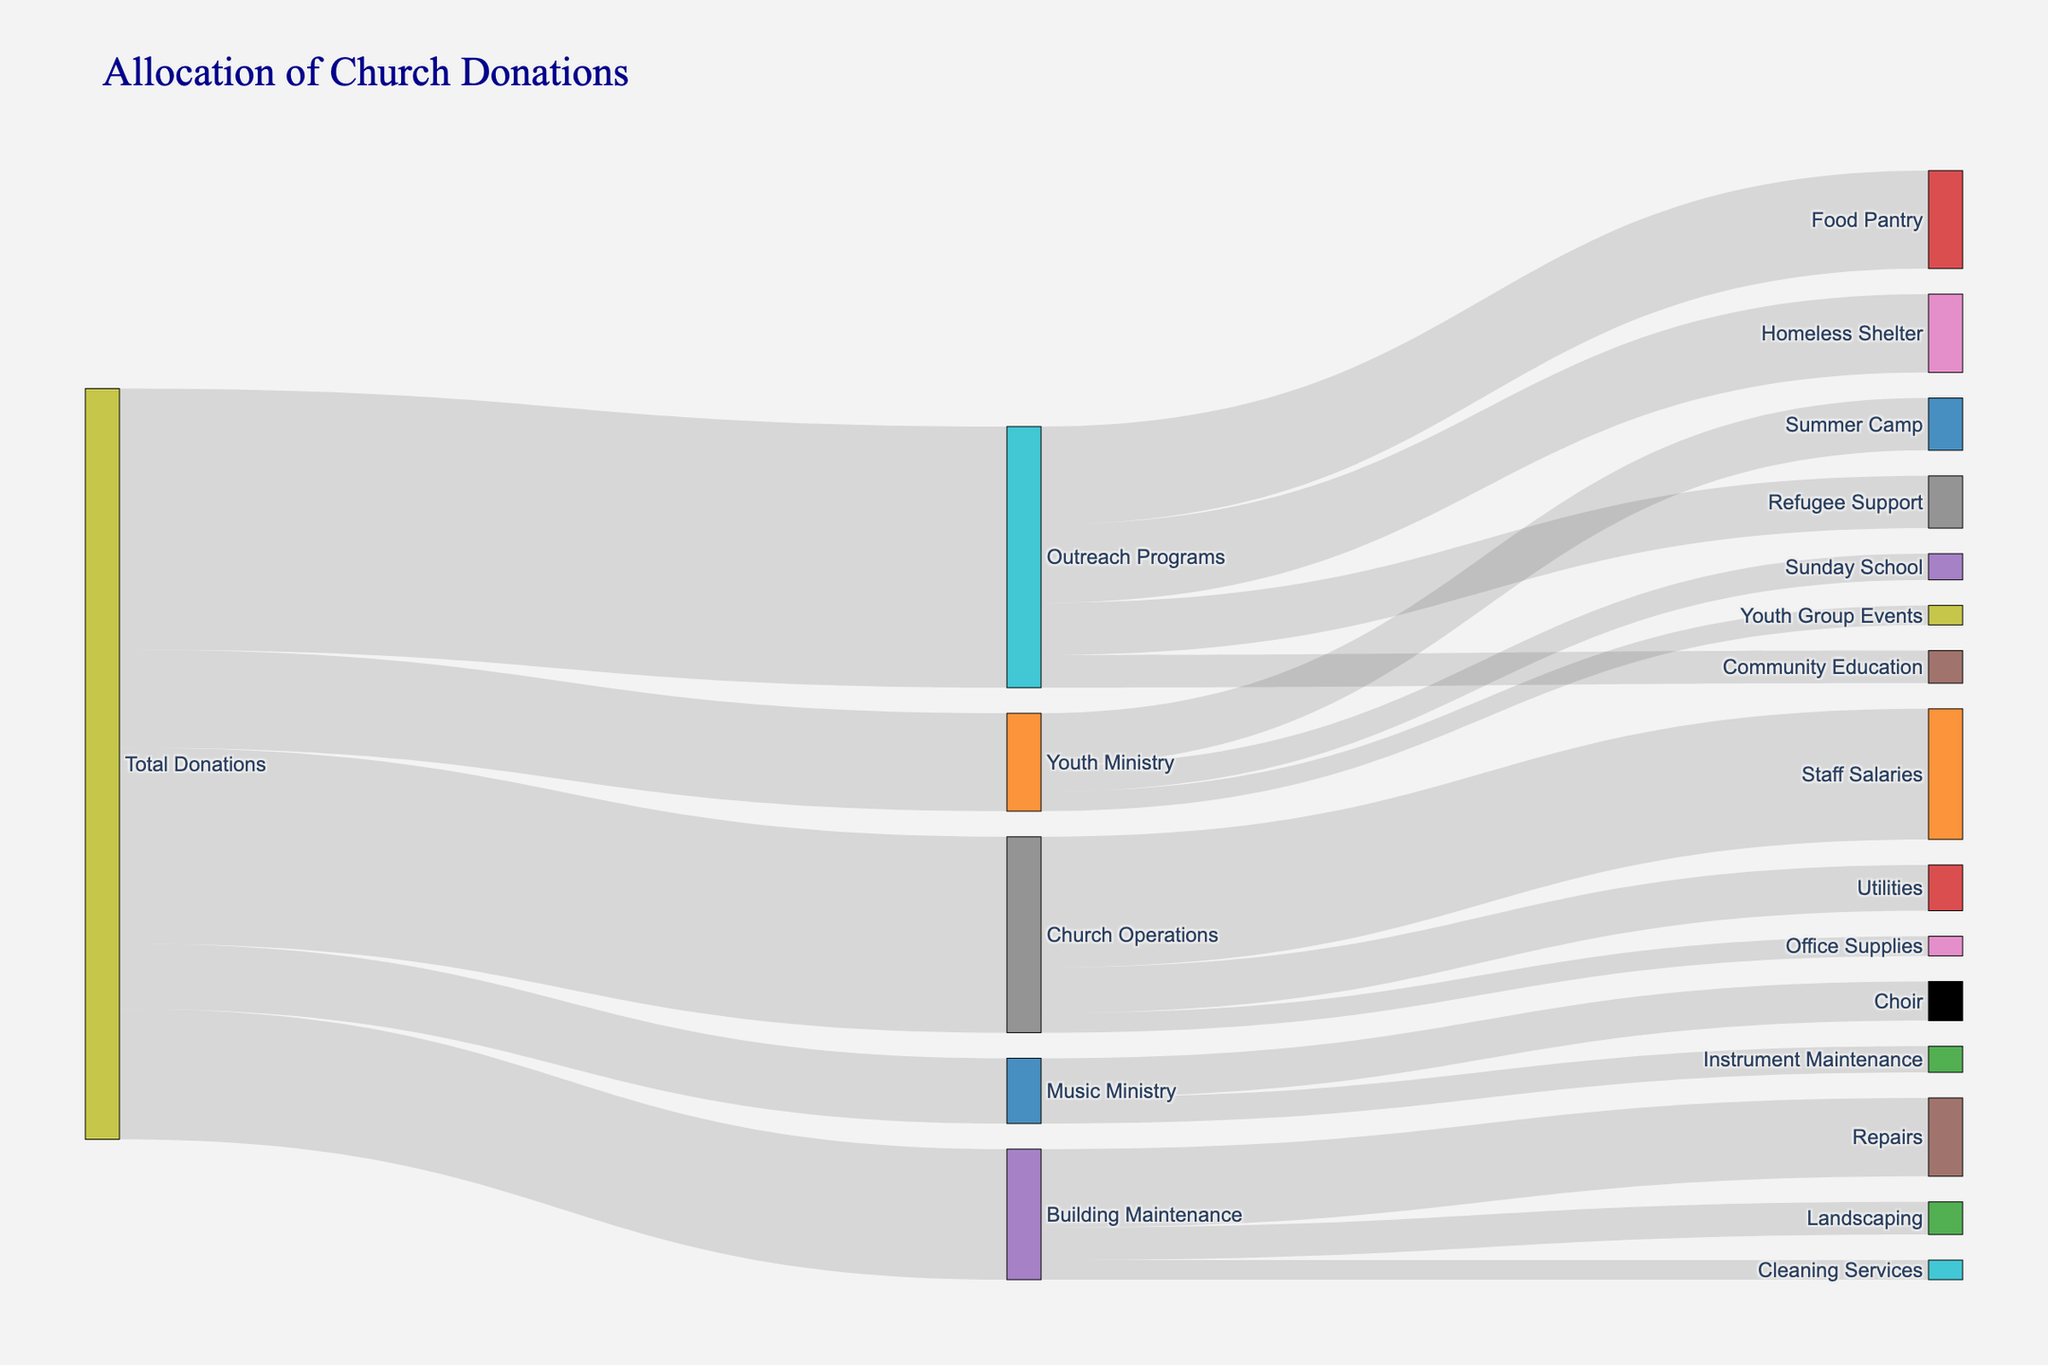Which category receives the highest amount of donations? The highest donation category is the one with the largest value linked to "Total Donations". By looking at the Sankey diagram, the "Outreach Programs" category receives the highest amount, which is 40,000.
Answer: Outreach Programs Which category receives the least amount of donations? The category with the smallest value linked to "Total Donations" represents the lowest amount. From the Sankey diagram, "Music Ministry" receives the least amount at 10,000.
Answer: Music Ministry What is the total amount allocated for Outreach Programs? Sum the values linked from "Outreach Programs" to each of its sub-categories: 15,000 (Food Pantry) + 12,000 (Homeless Shelter) + 8,000 (Refugee Support) + 5,000 (Community Education) = 40,000.
Answer: 40,000 How much more is allocated to Staff Salaries than to Utilities? The "Church Operations" node shows 20,000 for Staff Salaries and 7,000 for Utilities. The difference is 20,000 - 7,000 = 13,000.
Answer: 13,000 Which sub-category under Youth Ministry receives the most donations? By looking at the sub-categories linked from "Youth Ministry", Summer Camp receives 8,000, Sunday School receives 4,000, and Youth Group Events receives 3,000. The highest amount is for Summer Camp.
Answer: Summer Camp What combined amount is donated to Music Ministry and Building Maintenance? Sum the values linked from "Total Donations" to "Music Ministry" and "Building Maintenance": 10,000 (Music Ministry) + 20,000 (Building Maintenance) = 30,000
Answer: 30,000 Is there any sub-category under Building Maintenance that receives the same amount of donations as the entire Music Ministry? "Repairs" under Building Maintenance receives 12,000, "Landscaping" receives 5,000, and "Cleaning Services" receives 3,000. None are equal to 10,000 (Music Ministry).
Answer: No How much is allocated to Community Education compared to Refugee Support? The values linked from "Outreach Programs" show 5,000 for Community Education and 8,000 for Refugee Support. Community Education receives 3,000 less than Refugee Support.
Answer: 3,000 less Which has a larger allocation, Youth Ministry or Building Maintenance? "Youth Ministry" receives 15,000 while "Building Maintenance" receives 20,000. Building Maintenance has a larger allocation.
Answer: Building Maintenance 